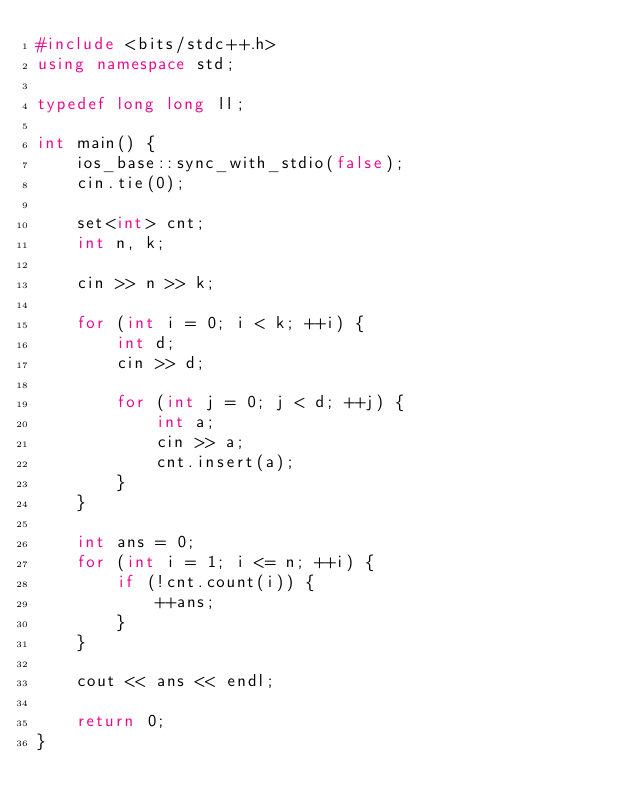<code> <loc_0><loc_0><loc_500><loc_500><_C++_>#include <bits/stdc++.h>
using namespace std;

typedef long long ll;

int main() {
	ios_base::sync_with_stdio(false);
	cin.tie(0);
	
	set<int> cnt;
	int n, k;
	
	cin >> n >> k;
	
	for (int i = 0; i < k; ++i) {
		int d;
		cin >> d;
		
		for (int j = 0; j < d; ++j) {
			int a;
			cin >> a;
			cnt.insert(a);
		}
	}
	
	int ans = 0;
	for (int i = 1; i <= n; ++i) {
		if (!cnt.count(i)) {
			++ans;
		}
	}
	
	cout << ans << endl;
	
	return 0;
}
</code> 